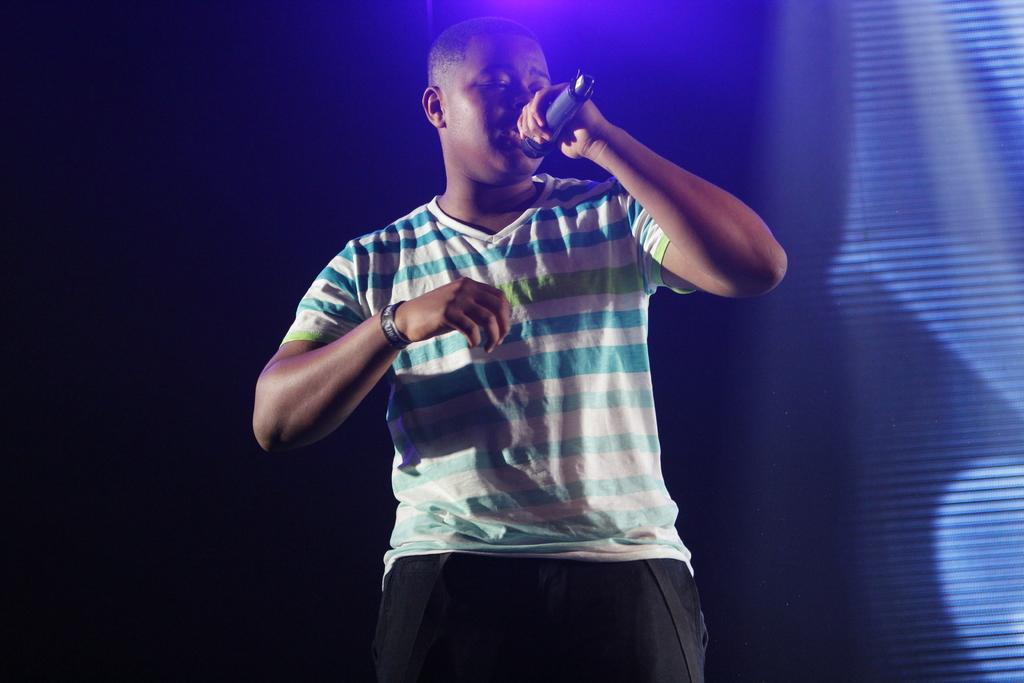What is the main subject of the image? The main subject of the image is a man. What is the man doing in the image? The man is standing and singing in the image. What object is the man holding in the image? The man is holding a microphone in the image. What type of clothing is the man wearing in the image? The man is wearing a T-shirt in the image. What type of toys can be seen on the table in the image? There are no toys present in the image. What letters are visible on the man's T-shirt in the image? The provided facts do not mention any letters on the man's T-shirt, so we cannot answer this question. 